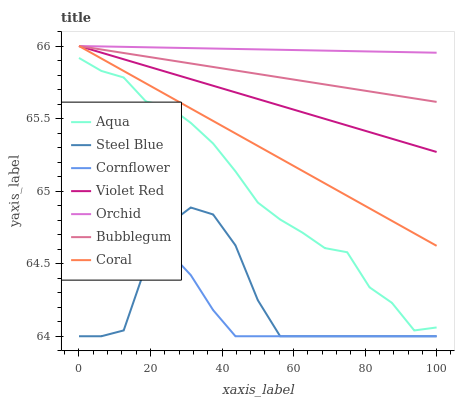Does Cornflower have the minimum area under the curve?
Answer yes or no. Yes. Does Orchid have the maximum area under the curve?
Answer yes or no. Yes. Does Violet Red have the minimum area under the curve?
Answer yes or no. No. Does Violet Red have the maximum area under the curve?
Answer yes or no. No. Is Bubblegum the smoothest?
Answer yes or no. Yes. Is Steel Blue the roughest?
Answer yes or no. Yes. Is Violet Red the smoothest?
Answer yes or no. No. Is Violet Red the roughest?
Answer yes or no. No. Does Cornflower have the lowest value?
Answer yes or no. Yes. Does Violet Red have the lowest value?
Answer yes or no. No. Does Orchid have the highest value?
Answer yes or no. Yes. Does Aqua have the highest value?
Answer yes or no. No. Is Steel Blue less than Aqua?
Answer yes or no. Yes. Is Coral greater than Cornflower?
Answer yes or no. Yes. Does Bubblegum intersect Orchid?
Answer yes or no. Yes. Is Bubblegum less than Orchid?
Answer yes or no. No. Is Bubblegum greater than Orchid?
Answer yes or no. No. Does Steel Blue intersect Aqua?
Answer yes or no. No. 